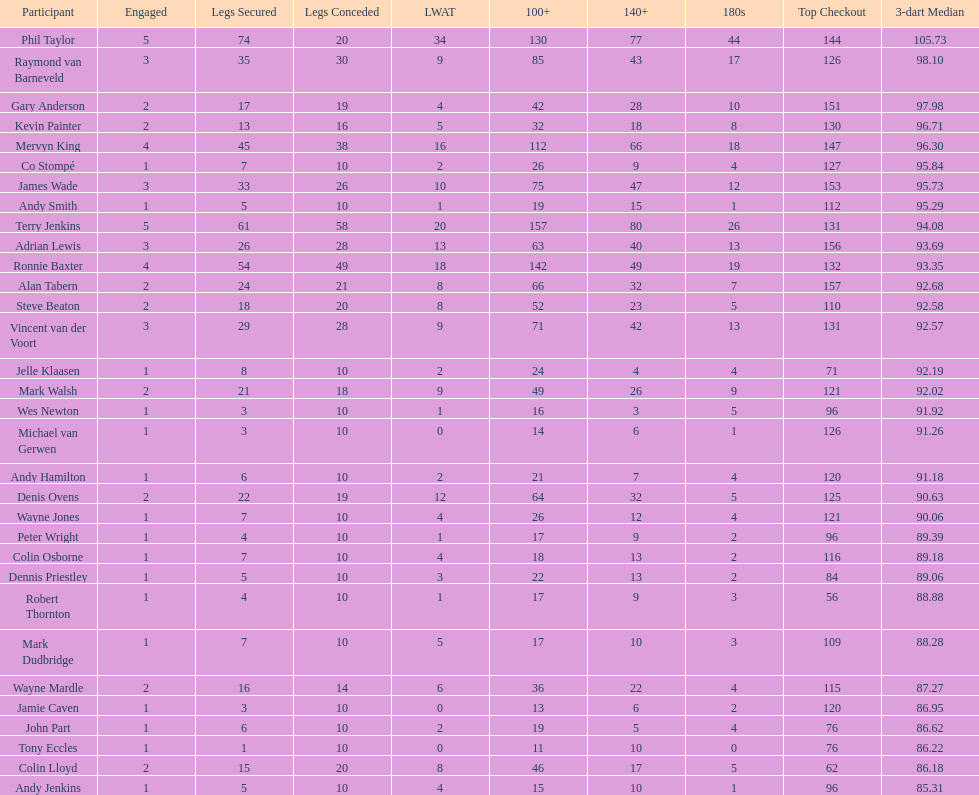List each of the players with a high checkout of 131. Terry Jenkins, Vincent van der Voort. 